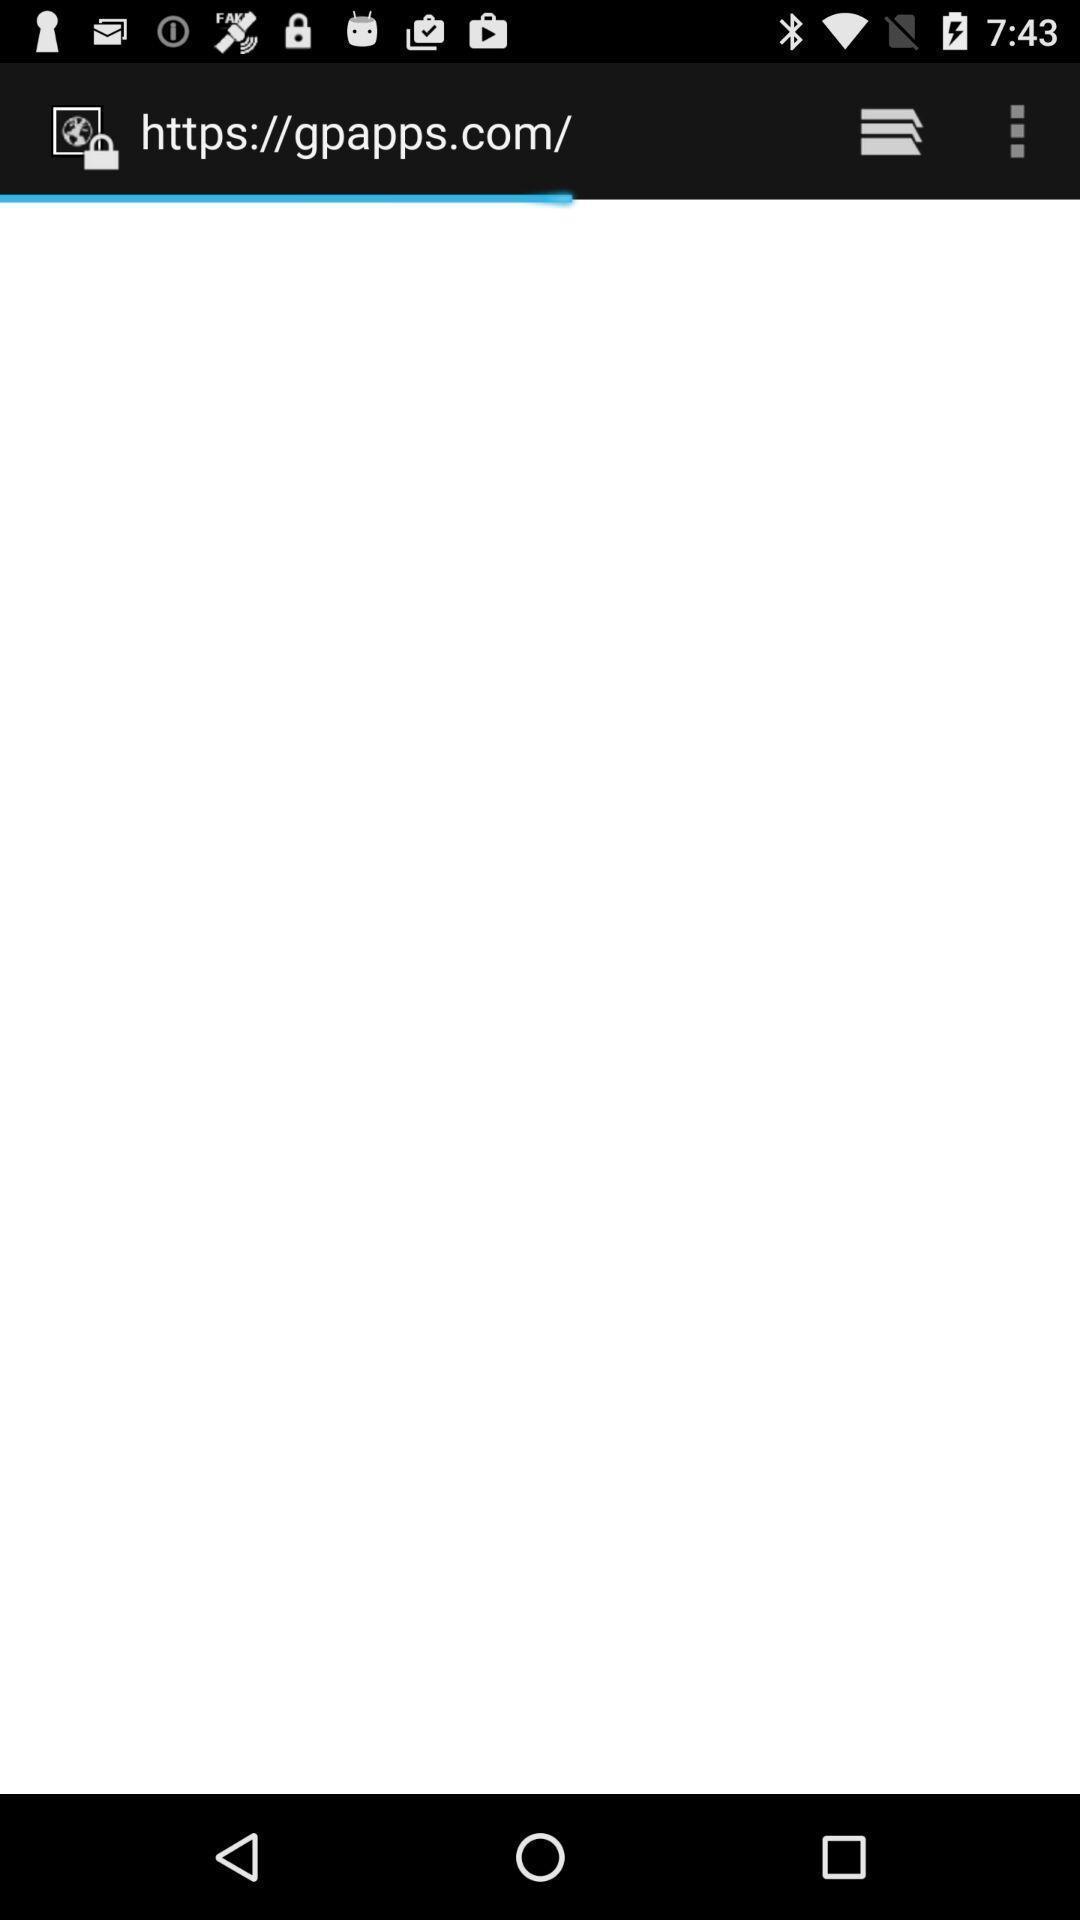Please provide a description for this image. Page displaying search options and buttons. 